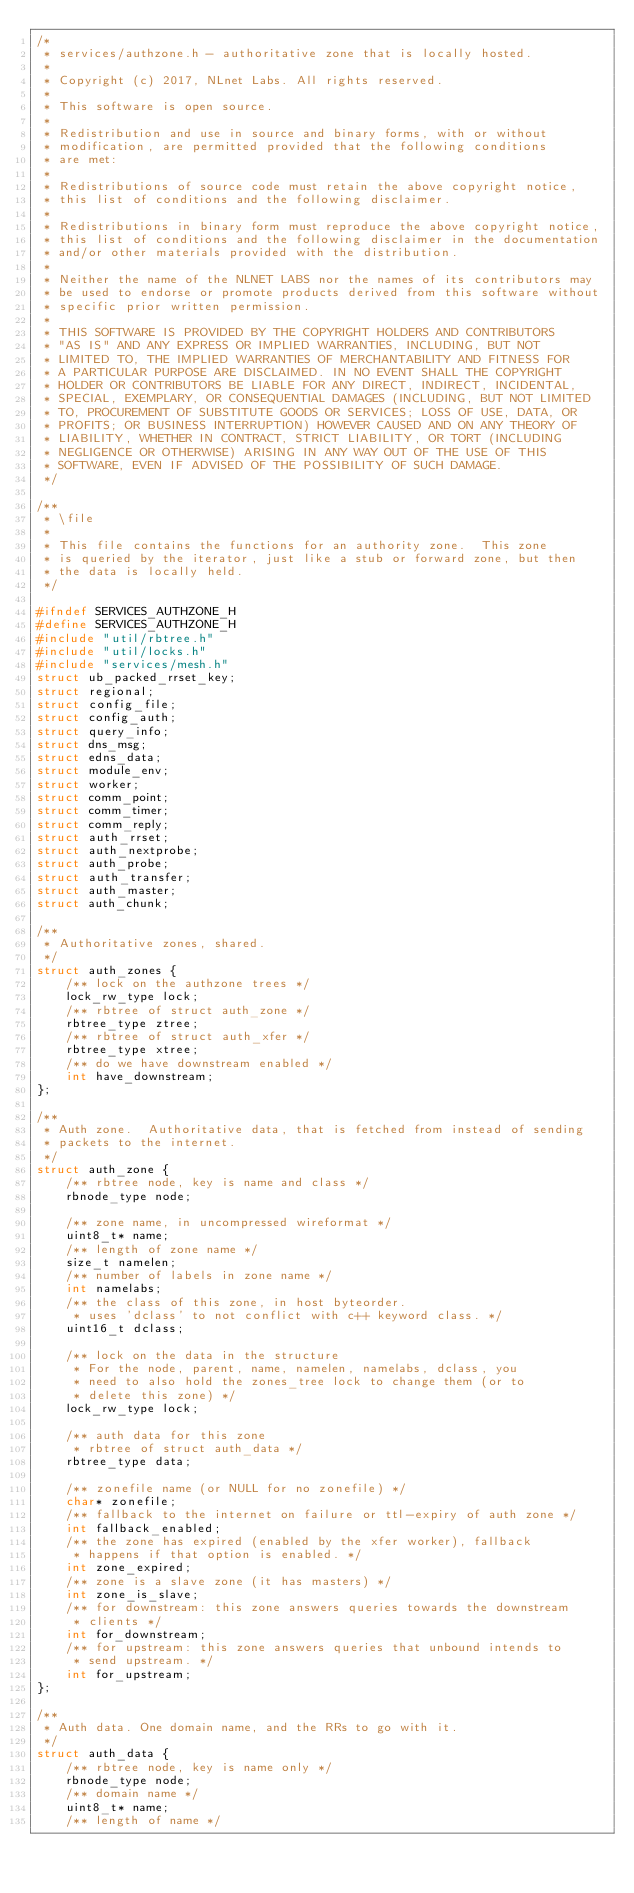<code> <loc_0><loc_0><loc_500><loc_500><_C_>/*
 * services/authzone.h - authoritative zone that is locally hosted.
 *
 * Copyright (c) 2017, NLnet Labs. All rights reserved.
 *
 * This software is open source.
 * 
 * Redistribution and use in source and binary forms, with or without
 * modification, are permitted provided that the following conditions
 * are met:
 * 
 * Redistributions of source code must retain the above copyright notice,
 * this list of conditions and the following disclaimer.
 * 
 * Redistributions in binary form must reproduce the above copyright notice,
 * this list of conditions and the following disclaimer in the documentation
 * and/or other materials provided with the distribution.
 * 
 * Neither the name of the NLNET LABS nor the names of its contributors may
 * be used to endorse or promote products derived from this software without
 * specific prior written permission.
 * 
 * THIS SOFTWARE IS PROVIDED BY THE COPYRIGHT HOLDERS AND CONTRIBUTORS
 * "AS IS" AND ANY EXPRESS OR IMPLIED WARRANTIES, INCLUDING, BUT NOT
 * LIMITED TO, THE IMPLIED WARRANTIES OF MERCHANTABILITY AND FITNESS FOR
 * A PARTICULAR PURPOSE ARE DISCLAIMED. IN NO EVENT SHALL THE COPYRIGHT
 * HOLDER OR CONTRIBUTORS BE LIABLE FOR ANY DIRECT, INDIRECT, INCIDENTAL,
 * SPECIAL, EXEMPLARY, OR CONSEQUENTIAL DAMAGES (INCLUDING, BUT NOT LIMITED
 * TO, PROCUREMENT OF SUBSTITUTE GOODS OR SERVICES; LOSS OF USE, DATA, OR
 * PROFITS; OR BUSINESS INTERRUPTION) HOWEVER CAUSED AND ON ANY THEORY OF
 * LIABILITY, WHETHER IN CONTRACT, STRICT LIABILITY, OR TORT (INCLUDING
 * NEGLIGENCE OR OTHERWISE) ARISING IN ANY WAY OUT OF THE USE OF THIS
 * SOFTWARE, EVEN IF ADVISED OF THE POSSIBILITY OF SUCH DAMAGE.
 */

/**
 * \file
 *
 * This file contains the functions for an authority zone.  This zone
 * is queried by the iterator, just like a stub or forward zone, but then
 * the data is locally held.
 */

#ifndef SERVICES_AUTHZONE_H
#define SERVICES_AUTHZONE_H
#include "util/rbtree.h"
#include "util/locks.h"
#include "services/mesh.h"
struct ub_packed_rrset_key;
struct regional;
struct config_file;
struct config_auth;
struct query_info;
struct dns_msg;
struct edns_data;
struct module_env;
struct worker;
struct comm_point;
struct comm_timer;
struct comm_reply;
struct auth_rrset;
struct auth_nextprobe;
struct auth_probe;
struct auth_transfer;
struct auth_master;
struct auth_chunk;

/**
 * Authoritative zones, shared.
 */
struct auth_zones {
	/** lock on the authzone trees */
	lock_rw_type lock;
	/** rbtree of struct auth_zone */
	rbtree_type ztree;
	/** rbtree of struct auth_xfer */
	rbtree_type xtree;
	/** do we have downstream enabled */
	int have_downstream;
};

/**
 * Auth zone.  Authoritative data, that is fetched from instead of sending
 * packets to the internet.
 */
struct auth_zone {
	/** rbtree node, key is name and class */
	rbnode_type node;

	/** zone name, in uncompressed wireformat */
	uint8_t* name;
	/** length of zone name */
	size_t namelen;
	/** number of labels in zone name */
	int namelabs;
	/** the class of this zone, in host byteorder.
	 * uses 'dclass' to not conflict with c++ keyword class. */
	uint16_t dclass;

	/** lock on the data in the structure
	 * For the node, parent, name, namelen, namelabs, dclass, you
	 * need to also hold the zones_tree lock to change them (or to
	 * delete this zone) */
	lock_rw_type lock;

	/** auth data for this zone
	 * rbtree of struct auth_data */
	rbtree_type data;

	/** zonefile name (or NULL for no zonefile) */
	char* zonefile;
	/** fallback to the internet on failure or ttl-expiry of auth zone */
	int fallback_enabled;
	/** the zone has expired (enabled by the xfer worker), fallback
	 * happens if that option is enabled. */
	int zone_expired;
	/** zone is a slave zone (it has masters) */
	int zone_is_slave;
	/** for downstream: this zone answers queries towards the downstream
	 * clients */
	int for_downstream;
	/** for upstream: this zone answers queries that unbound intends to
	 * send upstream. */
	int for_upstream;
};

/**
 * Auth data. One domain name, and the RRs to go with it.
 */
struct auth_data {
	/** rbtree node, key is name only */
	rbnode_type node;
	/** domain name */
	uint8_t* name;
	/** length of name */</code> 